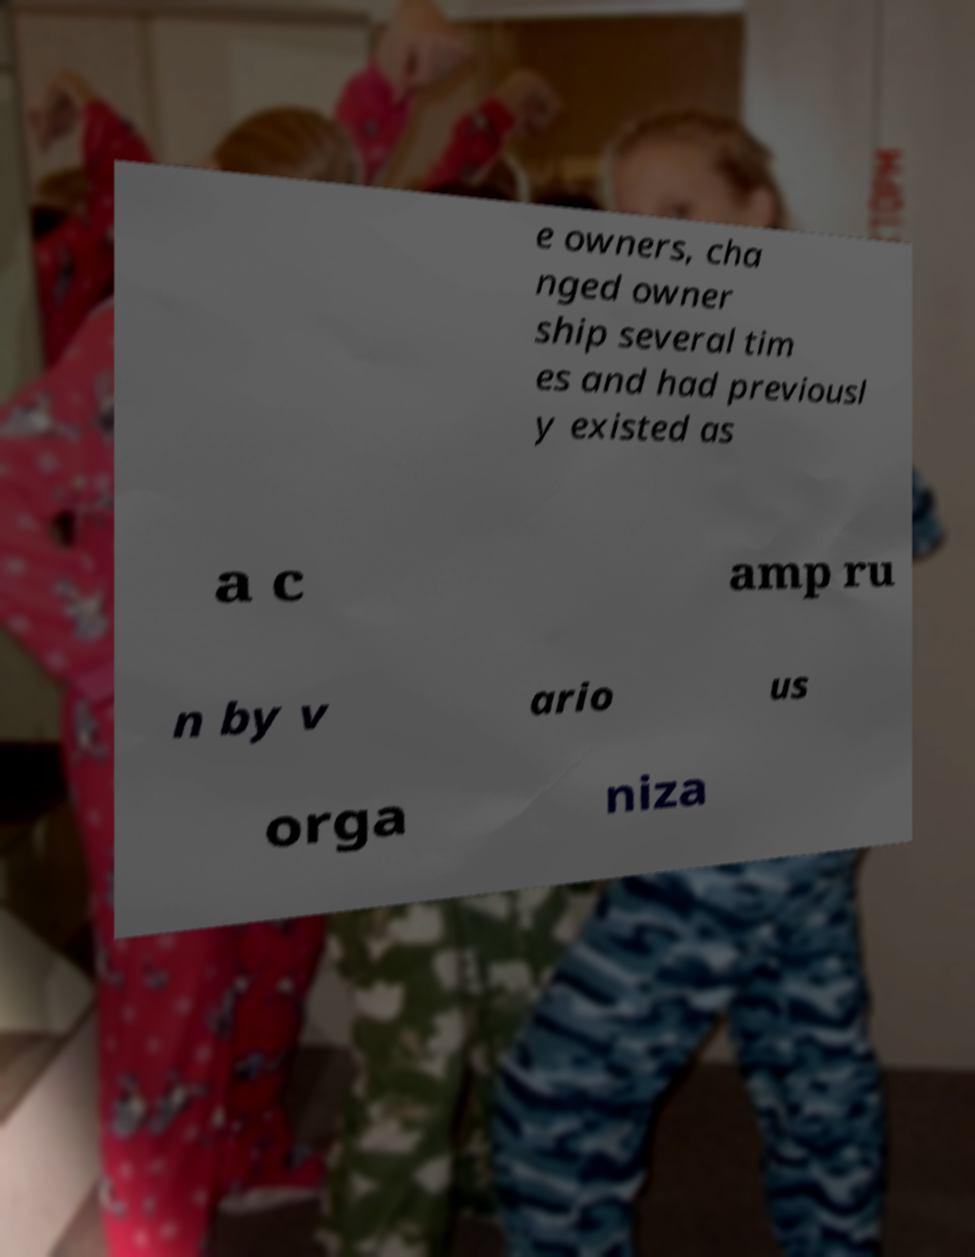Can you accurately transcribe the text from the provided image for me? e owners, cha nged owner ship several tim es and had previousl y existed as a c amp ru n by v ario us orga niza 